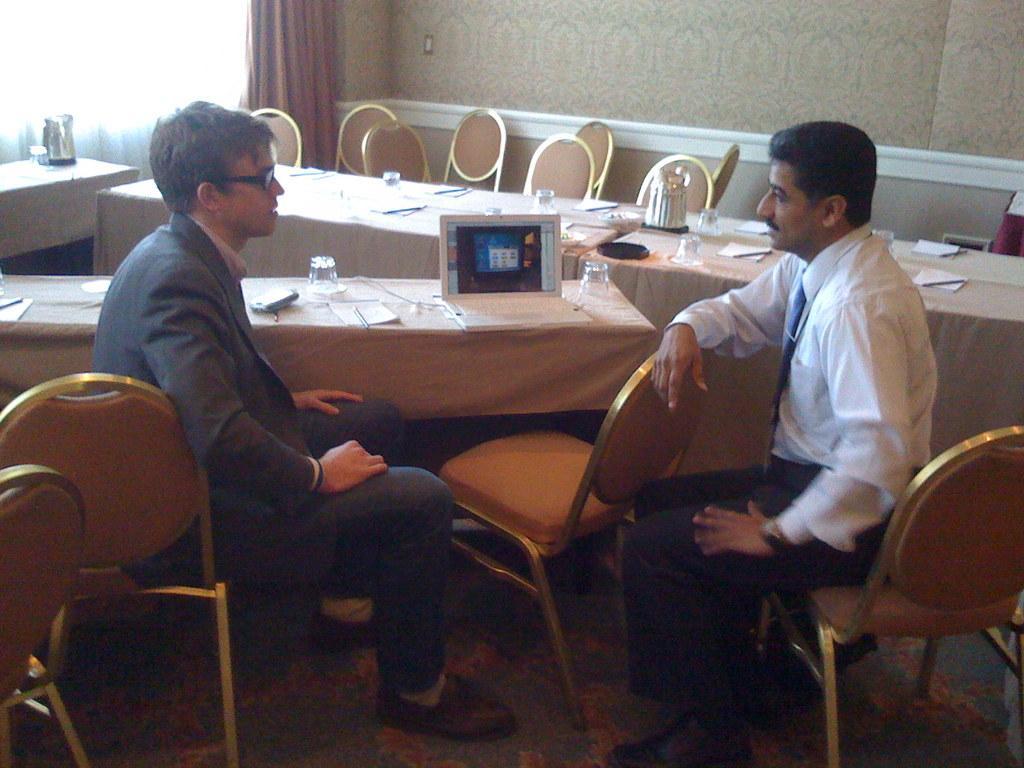In one or two sentences, can you explain what this image depicts? There are two persons in this image sitting on this chairs talking to each other and at the middle of the image there is a laptop which is placed on the table and there are water glasses on the table at the left side of the image there is a brown color curtain 